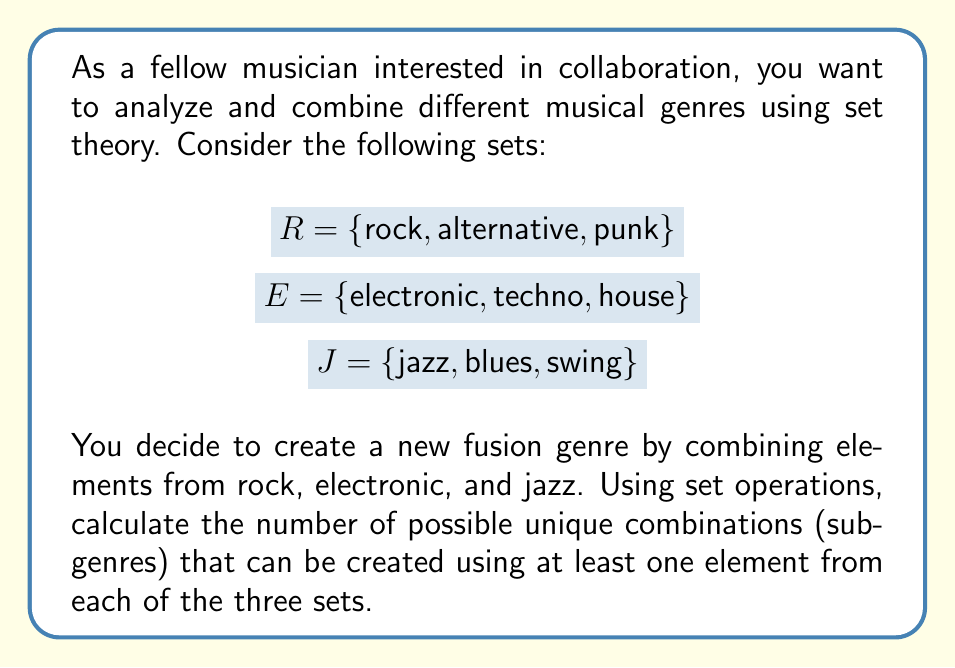Can you solve this math problem? To solve this problem, we'll use set theory and the multiplication principle. Let's approach this step-by-step:

1) First, we need to consider that for each set, we have two options: either include an element or not. However, we must include at least one element from each set.

2) For set $R$:
   - We must choose at least 1 element, so we have $2^3 - 1 = 7$ ways to choose from $R$.

3) For set $E$:
   - Similarly, we have $2^3 - 1 = 7$ ways to choose from $E$.

4) For set $J$:
   - Again, we have $2^3 - 1 = 7$ ways to choose from $J$.

5) Now, according to the multiplication principle, since we need to make a choice from each set, we multiply these numbers:

   $7 \times 7 \times 7 = 343$

6) This gives us the total number of possible unique combinations using at least one element from each of the three sets.

Therefore, there are 343 possible unique subgenres that can be created by combining elements from rock, electronic, and jazz, ensuring at least one element from each genre is included.
Answer: 343 